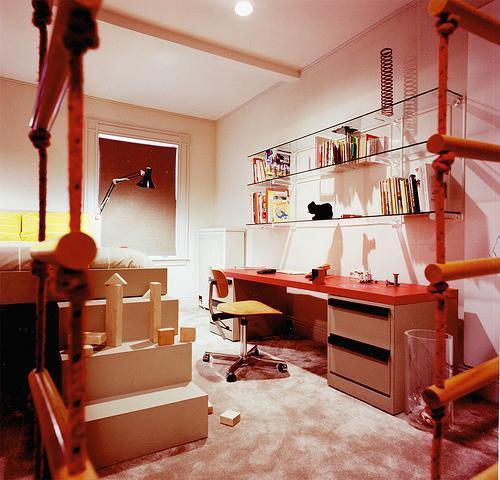How many trash cans are in the room?
Give a very brief answer. 1. How many beds are there?
Give a very brief answer. 2. 